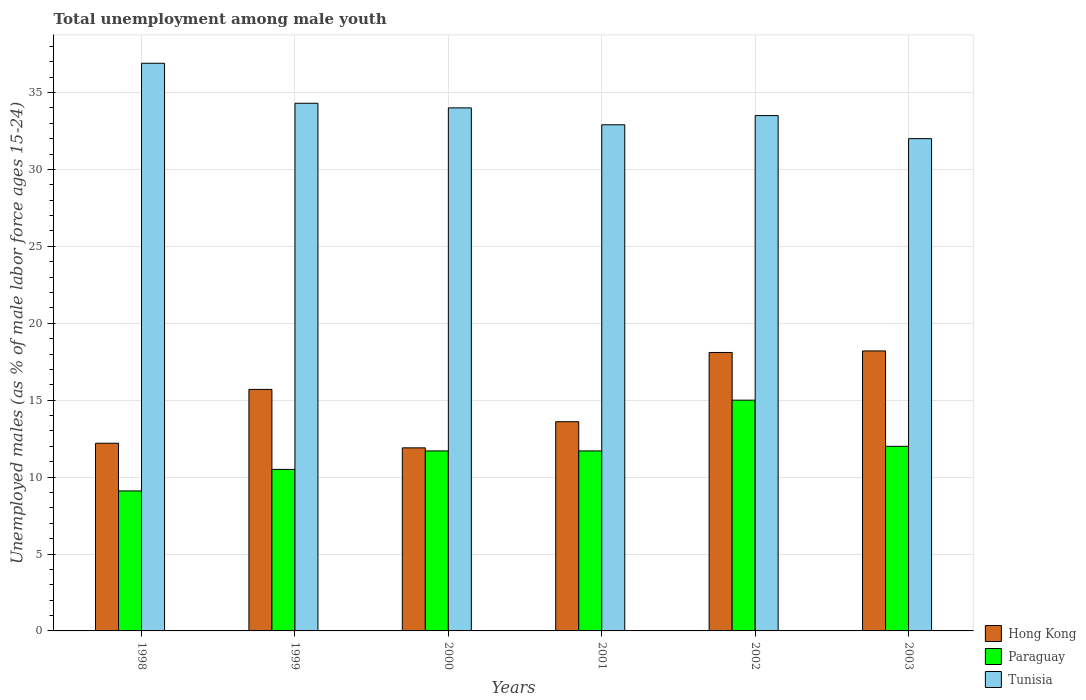How many different coloured bars are there?
Provide a succinct answer. 3. Are the number of bars per tick equal to the number of legend labels?
Keep it short and to the point. Yes. Are the number of bars on each tick of the X-axis equal?
Keep it short and to the point. Yes. What is the label of the 3rd group of bars from the left?
Offer a terse response. 2000. In how many cases, is the number of bars for a given year not equal to the number of legend labels?
Offer a terse response. 0. What is the percentage of unemployed males in in Paraguay in 1999?
Provide a succinct answer. 10.5. Across all years, what is the maximum percentage of unemployed males in in Tunisia?
Your response must be concise. 36.9. Across all years, what is the minimum percentage of unemployed males in in Hong Kong?
Your answer should be compact. 11.9. In which year was the percentage of unemployed males in in Tunisia minimum?
Provide a short and direct response. 2003. What is the total percentage of unemployed males in in Tunisia in the graph?
Your answer should be compact. 203.6. What is the difference between the percentage of unemployed males in in Tunisia in 2001 and that in 2003?
Keep it short and to the point. 0.9. What is the difference between the percentage of unemployed males in in Hong Kong in 2003 and the percentage of unemployed males in in Tunisia in 2001?
Provide a succinct answer. -14.7. What is the average percentage of unemployed males in in Tunisia per year?
Ensure brevity in your answer.  33.93. In the year 2001, what is the difference between the percentage of unemployed males in in Paraguay and percentage of unemployed males in in Hong Kong?
Your response must be concise. -1.9. What is the ratio of the percentage of unemployed males in in Paraguay in 1998 to that in 2002?
Provide a succinct answer. 0.61. What is the difference between the highest and the second highest percentage of unemployed males in in Tunisia?
Your answer should be very brief. 2.6. What is the difference between the highest and the lowest percentage of unemployed males in in Paraguay?
Offer a terse response. 5.9. What does the 1st bar from the left in 2001 represents?
Provide a succinct answer. Hong Kong. What does the 2nd bar from the right in 2002 represents?
Make the answer very short. Paraguay. Is it the case that in every year, the sum of the percentage of unemployed males in in Paraguay and percentage of unemployed males in in Hong Kong is greater than the percentage of unemployed males in in Tunisia?
Your response must be concise. No. Are all the bars in the graph horizontal?
Keep it short and to the point. No. How many years are there in the graph?
Ensure brevity in your answer.  6. Does the graph contain grids?
Provide a succinct answer. Yes. How many legend labels are there?
Keep it short and to the point. 3. What is the title of the graph?
Your response must be concise. Total unemployment among male youth. Does "Angola" appear as one of the legend labels in the graph?
Make the answer very short. No. What is the label or title of the Y-axis?
Provide a succinct answer. Unemployed males (as % of male labor force ages 15-24). What is the Unemployed males (as % of male labor force ages 15-24) of Hong Kong in 1998?
Give a very brief answer. 12.2. What is the Unemployed males (as % of male labor force ages 15-24) in Paraguay in 1998?
Provide a succinct answer. 9.1. What is the Unemployed males (as % of male labor force ages 15-24) in Tunisia in 1998?
Offer a very short reply. 36.9. What is the Unemployed males (as % of male labor force ages 15-24) in Hong Kong in 1999?
Provide a short and direct response. 15.7. What is the Unemployed males (as % of male labor force ages 15-24) in Tunisia in 1999?
Give a very brief answer. 34.3. What is the Unemployed males (as % of male labor force ages 15-24) of Hong Kong in 2000?
Your answer should be very brief. 11.9. What is the Unemployed males (as % of male labor force ages 15-24) in Paraguay in 2000?
Keep it short and to the point. 11.7. What is the Unemployed males (as % of male labor force ages 15-24) of Hong Kong in 2001?
Keep it short and to the point. 13.6. What is the Unemployed males (as % of male labor force ages 15-24) of Paraguay in 2001?
Make the answer very short. 11.7. What is the Unemployed males (as % of male labor force ages 15-24) of Tunisia in 2001?
Give a very brief answer. 32.9. What is the Unemployed males (as % of male labor force ages 15-24) in Hong Kong in 2002?
Offer a terse response. 18.1. What is the Unemployed males (as % of male labor force ages 15-24) in Tunisia in 2002?
Your answer should be very brief. 33.5. What is the Unemployed males (as % of male labor force ages 15-24) in Hong Kong in 2003?
Your answer should be compact. 18.2. What is the Unemployed males (as % of male labor force ages 15-24) in Paraguay in 2003?
Give a very brief answer. 12. Across all years, what is the maximum Unemployed males (as % of male labor force ages 15-24) in Hong Kong?
Ensure brevity in your answer.  18.2. Across all years, what is the maximum Unemployed males (as % of male labor force ages 15-24) of Paraguay?
Your response must be concise. 15. Across all years, what is the maximum Unemployed males (as % of male labor force ages 15-24) in Tunisia?
Your answer should be very brief. 36.9. Across all years, what is the minimum Unemployed males (as % of male labor force ages 15-24) of Hong Kong?
Give a very brief answer. 11.9. Across all years, what is the minimum Unemployed males (as % of male labor force ages 15-24) in Paraguay?
Your response must be concise. 9.1. Across all years, what is the minimum Unemployed males (as % of male labor force ages 15-24) in Tunisia?
Ensure brevity in your answer.  32. What is the total Unemployed males (as % of male labor force ages 15-24) in Hong Kong in the graph?
Your answer should be very brief. 89.7. What is the total Unemployed males (as % of male labor force ages 15-24) in Paraguay in the graph?
Provide a succinct answer. 70. What is the total Unemployed males (as % of male labor force ages 15-24) in Tunisia in the graph?
Provide a succinct answer. 203.6. What is the difference between the Unemployed males (as % of male labor force ages 15-24) in Hong Kong in 1998 and that in 1999?
Your answer should be compact. -3.5. What is the difference between the Unemployed males (as % of male labor force ages 15-24) of Hong Kong in 1998 and that in 2000?
Make the answer very short. 0.3. What is the difference between the Unemployed males (as % of male labor force ages 15-24) of Paraguay in 1998 and that in 2000?
Ensure brevity in your answer.  -2.6. What is the difference between the Unemployed males (as % of male labor force ages 15-24) in Paraguay in 1998 and that in 2002?
Make the answer very short. -5.9. What is the difference between the Unemployed males (as % of male labor force ages 15-24) in Hong Kong in 1999 and that in 2000?
Your answer should be compact. 3.8. What is the difference between the Unemployed males (as % of male labor force ages 15-24) of Paraguay in 1999 and that in 2001?
Make the answer very short. -1.2. What is the difference between the Unemployed males (as % of male labor force ages 15-24) of Tunisia in 1999 and that in 2002?
Offer a terse response. 0.8. What is the difference between the Unemployed males (as % of male labor force ages 15-24) of Hong Kong in 1999 and that in 2003?
Provide a succinct answer. -2.5. What is the difference between the Unemployed males (as % of male labor force ages 15-24) of Paraguay in 1999 and that in 2003?
Your answer should be very brief. -1.5. What is the difference between the Unemployed males (as % of male labor force ages 15-24) in Paraguay in 2000 and that in 2001?
Your answer should be very brief. 0. What is the difference between the Unemployed males (as % of male labor force ages 15-24) of Tunisia in 2000 and that in 2001?
Your response must be concise. 1.1. What is the difference between the Unemployed males (as % of male labor force ages 15-24) of Hong Kong in 2000 and that in 2002?
Your answer should be very brief. -6.2. What is the difference between the Unemployed males (as % of male labor force ages 15-24) in Paraguay in 2000 and that in 2002?
Give a very brief answer. -3.3. What is the difference between the Unemployed males (as % of male labor force ages 15-24) in Hong Kong in 2000 and that in 2003?
Offer a very short reply. -6.3. What is the difference between the Unemployed males (as % of male labor force ages 15-24) of Hong Kong in 2001 and that in 2003?
Offer a terse response. -4.6. What is the difference between the Unemployed males (as % of male labor force ages 15-24) in Tunisia in 2001 and that in 2003?
Keep it short and to the point. 0.9. What is the difference between the Unemployed males (as % of male labor force ages 15-24) in Paraguay in 2002 and that in 2003?
Provide a succinct answer. 3. What is the difference between the Unemployed males (as % of male labor force ages 15-24) of Hong Kong in 1998 and the Unemployed males (as % of male labor force ages 15-24) of Tunisia in 1999?
Provide a short and direct response. -22.1. What is the difference between the Unemployed males (as % of male labor force ages 15-24) in Paraguay in 1998 and the Unemployed males (as % of male labor force ages 15-24) in Tunisia in 1999?
Your answer should be very brief. -25.2. What is the difference between the Unemployed males (as % of male labor force ages 15-24) in Hong Kong in 1998 and the Unemployed males (as % of male labor force ages 15-24) in Tunisia in 2000?
Provide a short and direct response. -21.8. What is the difference between the Unemployed males (as % of male labor force ages 15-24) of Paraguay in 1998 and the Unemployed males (as % of male labor force ages 15-24) of Tunisia in 2000?
Provide a short and direct response. -24.9. What is the difference between the Unemployed males (as % of male labor force ages 15-24) in Hong Kong in 1998 and the Unemployed males (as % of male labor force ages 15-24) in Tunisia in 2001?
Your answer should be very brief. -20.7. What is the difference between the Unemployed males (as % of male labor force ages 15-24) in Paraguay in 1998 and the Unemployed males (as % of male labor force ages 15-24) in Tunisia in 2001?
Your answer should be compact. -23.8. What is the difference between the Unemployed males (as % of male labor force ages 15-24) of Hong Kong in 1998 and the Unemployed males (as % of male labor force ages 15-24) of Tunisia in 2002?
Your response must be concise. -21.3. What is the difference between the Unemployed males (as % of male labor force ages 15-24) of Paraguay in 1998 and the Unemployed males (as % of male labor force ages 15-24) of Tunisia in 2002?
Your answer should be compact. -24.4. What is the difference between the Unemployed males (as % of male labor force ages 15-24) of Hong Kong in 1998 and the Unemployed males (as % of male labor force ages 15-24) of Tunisia in 2003?
Provide a short and direct response. -19.8. What is the difference between the Unemployed males (as % of male labor force ages 15-24) of Paraguay in 1998 and the Unemployed males (as % of male labor force ages 15-24) of Tunisia in 2003?
Provide a short and direct response. -22.9. What is the difference between the Unemployed males (as % of male labor force ages 15-24) in Hong Kong in 1999 and the Unemployed males (as % of male labor force ages 15-24) in Tunisia in 2000?
Make the answer very short. -18.3. What is the difference between the Unemployed males (as % of male labor force ages 15-24) in Paraguay in 1999 and the Unemployed males (as % of male labor force ages 15-24) in Tunisia in 2000?
Offer a terse response. -23.5. What is the difference between the Unemployed males (as % of male labor force ages 15-24) of Hong Kong in 1999 and the Unemployed males (as % of male labor force ages 15-24) of Paraguay in 2001?
Keep it short and to the point. 4. What is the difference between the Unemployed males (as % of male labor force ages 15-24) of Hong Kong in 1999 and the Unemployed males (as % of male labor force ages 15-24) of Tunisia in 2001?
Your answer should be compact. -17.2. What is the difference between the Unemployed males (as % of male labor force ages 15-24) of Paraguay in 1999 and the Unemployed males (as % of male labor force ages 15-24) of Tunisia in 2001?
Your response must be concise. -22.4. What is the difference between the Unemployed males (as % of male labor force ages 15-24) of Hong Kong in 1999 and the Unemployed males (as % of male labor force ages 15-24) of Tunisia in 2002?
Make the answer very short. -17.8. What is the difference between the Unemployed males (as % of male labor force ages 15-24) in Hong Kong in 1999 and the Unemployed males (as % of male labor force ages 15-24) in Paraguay in 2003?
Ensure brevity in your answer.  3.7. What is the difference between the Unemployed males (as % of male labor force ages 15-24) in Hong Kong in 1999 and the Unemployed males (as % of male labor force ages 15-24) in Tunisia in 2003?
Provide a short and direct response. -16.3. What is the difference between the Unemployed males (as % of male labor force ages 15-24) in Paraguay in 1999 and the Unemployed males (as % of male labor force ages 15-24) in Tunisia in 2003?
Offer a very short reply. -21.5. What is the difference between the Unemployed males (as % of male labor force ages 15-24) of Hong Kong in 2000 and the Unemployed males (as % of male labor force ages 15-24) of Paraguay in 2001?
Your answer should be very brief. 0.2. What is the difference between the Unemployed males (as % of male labor force ages 15-24) of Paraguay in 2000 and the Unemployed males (as % of male labor force ages 15-24) of Tunisia in 2001?
Ensure brevity in your answer.  -21.2. What is the difference between the Unemployed males (as % of male labor force ages 15-24) in Hong Kong in 2000 and the Unemployed males (as % of male labor force ages 15-24) in Paraguay in 2002?
Provide a short and direct response. -3.1. What is the difference between the Unemployed males (as % of male labor force ages 15-24) in Hong Kong in 2000 and the Unemployed males (as % of male labor force ages 15-24) in Tunisia in 2002?
Your answer should be very brief. -21.6. What is the difference between the Unemployed males (as % of male labor force ages 15-24) in Paraguay in 2000 and the Unemployed males (as % of male labor force ages 15-24) in Tunisia in 2002?
Make the answer very short. -21.8. What is the difference between the Unemployed males (as % of male labor force ages 15-24) of Hong Kong in 2000 and the Unemployed males (as % of male labor force ages 15-24) of Paraguay in 2003?
Your response must be concise. -0.1. What is the difference between the Unemployed males (as % of male labor force ages 15-24) of Hong Kong in 2000 and the Unemployed males (as % of male labor force ages 15-24) of Tunisia in 2003?
Keep it short and to the point. -20.1. What is the difference between the Unemployed males (as % of male labor force ages 15-24) of Paraguay in 2000 and the Unemployed males (as % of male labor force ages 15-24) of Tunisia in 2003?
Keep it short and to the point. -20.3. What is the difference between the Unemployed males (as % of male labor force ages 15-24) in Hong Kong in 2001 and the Unemployed males (as % of male labor force ages 15-24) in Paraguay in 2002?
Your response must be concise. -1.4. What is the difference between the Unemployed males (as % of male labor force ages 15-24) of Hong Kong in 2001 and the Unemployed males (as % of male labor force ages 15-24) of Tunisia in 2002?
Your response must be concise. -19.9. What is the difference between the Unemployed males (as % of male labor force ages 15-24) in Paraguay in 2001 and the Unemployed males (as % of male labor force ages 15-24) in Tunisia in 2002?
Offer a terse response. -21.8. What is the difference between the Unemployed males (as % of male labor force ages 15-24) of Hong Kong in 2001 and the Unemployed males (as % of male labor force ages 15-24) of Paraguay in 2003?
Keep it short and to the point. 1.6. What is the difference between the Unemployed males (as % of male labor force ages 15-24) in Hong Kong in 2001 and the Unemployed males (as % of male labor force ages 15-24) in Tunisia in 2003?
Your answer should be very brief. -18.4. What is the difference between the Unemployed males (as % of male labor force ages 15-24) in Paraguay in 2001 and the Unemployed males (as % of male labor force ages 15-24) in Tunisia in 2003?
Provide a succinct answer. -20.3. What is the difference between the Unemployed males (as % of male labor force ages 15-24) in Hong Kong in 2002 and the Unemployed males (as % of male labor force ages 15-24) in Paraguay in 2003?
Give a very brief answer. 6.1. What is the difference between the Unemployed males (as % of male labor force ages 15-24) in Paraguay in 2002 and the Unemployed males (as % of male labor force ages 15-24) in Tunisia in 2003?
Make the answer very short. -17. What is the average Unemployed males (as % of male labor force ages 15-24) of Hong Kong per year?
Your response must be concise. 14.95. What is the average Unemployed males (as % of male labor force ages 15-24) in Paraguay per year?
Your response must be concise. 11.67. What is the average Unemployed males (as % of male labor force ages 15-24) of Tunisia per year?
Provide a short and direct response. 33.93. In the year 1998, what is the difference between the Unemployed males (as % of male labor force ages 15-24) of Hong Kong and Unemployed males (as % of male labor force ages 15-24) of Tunisia?
Make the answer very short. -24.7. In the year 1998, what is the difference between the Unemployed males (as % of male labor force ages 15-24) of Paraguay and Unemployed males (as % of male labor force ages 15-24) of Tunisia?
Offer a terse response. -27.8. In the year 1999, what is the difference between the Unemployed males (as % of male labor force ages 15-24) of Hong Kong and Unemployed males (as % of male labor force ages 15-24) of Paraguay?
Your answer should be very brief. 5.2. In the year 1999, what is the difference between the Unemployed males (as % of male labor force ages 15-24) of Hong Kong and Unemployed males (as % of male labor force ages 15-24) of Tunisia?
Ensure brevity in your answer.  -18.6. In the year 1999, what is the difference between the Unemployed males (as % of male labor force ages 15-24) in Paraguay and Unemployed males (as % of male labor force ages 15-24) in Tunisia?
Offer a terse response. -23.8. In the year 2000, what is the difference between the Unemployed males (as % of male labor force ages 15-24) of Hong Kong and Unemployed males (as % of male labor force ages 15-24) of Tunisia?
Provide a succinct answer. -22.1. In the year 2000, what is the difference between the Unemployed males (as % of male labor force ages 15-24) of Paraguay and Unemployed males (as % of male labor force ages 15-24) of Tunisia?
Offer a terse response. -22.3. In the year 2001, what is the difference between the Unemployed males (as % of male labor force ages 15-24) in Hong Kong and Unemployed males (as % of male labor force ages 15-24) in Tunisia?
Give a very brief answer. -19.3. In the year 2001, what is the difference between the Unemployed males (as % of male labor force ages 15-24) in Paraguay and Unemployed males (as % of male labor force ages 15-24) in Tunisia?
Provide a short and direct response. -21.2. In the year 2002, what is the difference between the Unemployed males (as % of male labor force ages 15-24) of Hong Kong and Unemployed males (as % of male labor force ages 15-24) of Tunisia?
Provide a succinct answer. -15.4. In the year 2002, what is the difference between the Unemployed males (as % of male labor force ages 15-24) of Paraguay and Unemployed males (as % of male labor force ages 15-24) of Tunisia?
Offer a very short reply. -18.5. In the year 2003, what is the difference between the Unemployed males (as % of male labor force ages 15-24) of Hong Kong and Unemployed males (as % of male labor force ages 15-24) of Paraguay?
Provide a succinct answer. 6.2. In the year 2003, what is the difference between the Unemployed males (as % of male labor force ages 15-24) of Hong Kong and Unemployed males (as % of male labor force ages 15-24) of Tunisia?
Offer a very short reply. -13.8. In the year 2003, what is the difference between the Unemployed males (as % of male labor force ages 15-24) in Paraguay and Unemployed males (as % of male labor force ages 15-24) in Tunisia?
Ensure brevity in your answer.  -20. What is the ratio of the Unemployed males (as % of male labor force ages 15-24) of Hong Kong in 1998 to that in 1999?
Ensure brevity in your answer.  0.78. What is the ratio of the Unemployed males (as % of male labor force ages 15-24) in Paraguay in 1998 to that in 1999?
Make the answer very short. 0.87. What is the ratio of the Unemployed males (as % of male labor force ages 15-24) in Tunisia in 1998 to that in 1999?
Your answer should be compact. 1.08. What is the ratio of the Unemployed males (as % of male labor force ages 15-24) in Hong Kong in 1998 to that in 2000?
Ensure brevity in your answer.  1.03. What is the ratio of the Unemployed males (as % of male labor force ages 15-24) in Paraguay in 1998 to that in 2000?
Offer a terse response. 0.78. What is the ratio of the Unemployed males (as % of male labor force ages 15-24) in Tunisia in 1998 to that in 2000?
Your response must be concise. 1.09. What is the ratio of the Unemployed males (as % of male labor force ages 15-24) in Hong Kong in 1998 to that in 2001?
Your answer should be compact. 0.9. What is the ratio of the Unemployed males (as % of male labor force ages 15-24) in Paraguay in 1998 to that in 2001?
Offer a very short reply. 0.78. What is the ratio of the Unemployed males (as % of male labor force ages 15-24) of Tunisia in 1998 to that in 2001?
Give a very brief answer. 1.12. What is the ratio of the Unemployed males (as % of male labor force ages 15-24) in Hong Kong in 1998 to that in 2002?
Provide a succinct answer. 0.67. What is the ratio of the Unemployed males (as % of male labor force ages 15-24) of Paraguay in 1998 to that in 2002?
Provide a short and direct response. 0.61. What is the ratio of the Unemployed males (as % of male labor force ages 15-24) of Tunisia in 1998 to that in 2002?
Your response must be concise. 1.1. What is the ratio of the Unemployed males (as % of male labor force ages 15-24) in Hong Kong in 1998 to that in 2003?
Your answer should be compact. 0.67. What is the ratio of the Unemployed males (as % of male labor force ages 15-24) in Paraguay in 1998 to that in 2003?
Keep it short and to the point. 0.76. What is the ratio of the Unemployed males (as % of male labor force ages 15-24) of Tunisia in 1998 to that in 2003?
Ensure brevity in your answer.  1.15. What is the ratio of the Unemployed males (as % of male labor force ages 15-24) of Hong Kong in 1999 to that in 2000?
Your answer should be very brief. 1.32. What is the ratio of the Unemployed males (as % of male labor force ages 15-24) of Paraguay in 1999 to that in 2000?
Ensure brevity in your answer.  0.9. What is the ratio of the Unemployed males (as % of male labor force ages 15-24) in Tunisia in 1999 to that in 2000?
Your answer should be very brief. 1.01. What is the ratio of the Unemployed males (as % of male labor force ages 15-24) of Hong Kong in 1999 to that in 2001?
Provide a succinct answer. 1.15. What is the ratio of the Unemployed males (as % of male labor force ages 15-24) of Paraguay in 1999 to that in 2001?
Offer a very short reply. 0.9. What is the ratio of the Unemployed males (as % of male labor force ages 15-24) of Tunisia in 1999 to that in 2001?
Ensure brevity in your answer.  1.04. What is the ratio of the Unemployed males (as % of male labor force ages 15-24) of Hong Kong in 1999 to that in 2002?
Your response must be concise. 0.87. What is the ratio of the Unemployed males (as % of male labor force ages 15-24) in Tunisia in 1999 to that in 2002?
Offer a very short reply. 1.02. What is the ratio of the Unemployed males (as % of male labor force ages 15-24) in Hong Kong in 1999 to that in 2003?
Provide a succinct answer. 0.86. What is the ratio of the Unemployed males (as % of male labor force ages 15-24) of Paraguay in 1999 to that in 2003?
Offer a terse response. 0.88. What is the ratio of the Unemployed males (as % of male labor force ages 15-24) in Tunisia in 1999 to that in 2003?
Provide a short and direct response. 1.07. What is the ratio of the Unemployed males (as % of male labor force ages 15-24) in Paraguay in 2000 to that in 2001?
Your answer should be very brief. 1. What is the ratio of the Unemployed males (as % of male labor force ages 15-24) in Tunisia in 2000 to that in 2001?
Offer a terse response. 1.03. What is the ratio of the Unemployed males (as % of male labor force ages 15-24) of Hong Kong in 2000 to that in 2002?
Offer a very short reply. 0.66. What is the ratio of the Unemployed males (as % of male labor force ages 15-24) in Paraguay in 2000 to that in 2002?
Your response must be concise. 0.78. What is the ratio of the Unemployed males (as % of male labor force ages 15-24) of Tunisia in 2000 to that in 2002?
Provide a short and direct response. 1.01. What is the ratio of the Unemployed males (as % of male labor force ages 15-24) in Hong Kong in 2000 to that in 2003?
Ensure brevity in your answer.  0.65. What is the ratio of the Unemployed males (as % of male labor force ages 15-24) in Tunisia in 2000 to that in 2003?
Your response must be concise. 1.06. What is the ratio of the Unemployed males (as % of male labor force ages 15-24) of Hong Kong in 2001 to that in 2002?
Offer a terse response. 0.75. What is the ratio of the Unemployed males (as % of male labor force ages 15-24) of Paraguay in 2001 to that in 2002?
Offer a very short reply. 0.78. What is the ratio of the Unemployed males (as % of male labor force ages 15-24) in Tunisia in 2001 to that in 2002?
Make the answer very short. 0.98. What is the ratio of the Unemployed males (as % of male labor force ages 15-24) in Hong Kong in 2001 to that in 2003?
Your answer should be compact. 0.75. What is the ratio of the Unemployed males (as % of male labor force ages 15-24) in Paraguay in 2001 to that in 2003?
Provide a short and direct response. 0.97. What is the ratio of the Unemployed males (as % of male labor force ages 15-24) of Tunisia in 2001 to that in 2003?
Your response must be concise. 1.03. What is the ratio of the Unemployed males (as % of male labor force ages 15-24) in Hong Kong in 2002 to that in 2003?
Ensure brevity in your answer.  0.99. What is the ratio of the Unemployed males (as % of male labor force ages 15-24) in Paraguay in 2002 to that in 2003?
Offer a very short reply. 1.25. What is the ratio of the Unemployed males (as % of male labor force ages 15-24) of Tunisia in 2002 to that in 2003?
Give a very brief answer. 1.05. What is the difference between the highest and the second highest Unemployed males (as % of male labor force ages 15-24) in Paraguay?
Provide a succinct answer. 3. What is the difference between the highest and the lowest Unemployed males (as % of male labor force ages 15-24) in Hong Kong?
Offer a terse response. 6.3. 